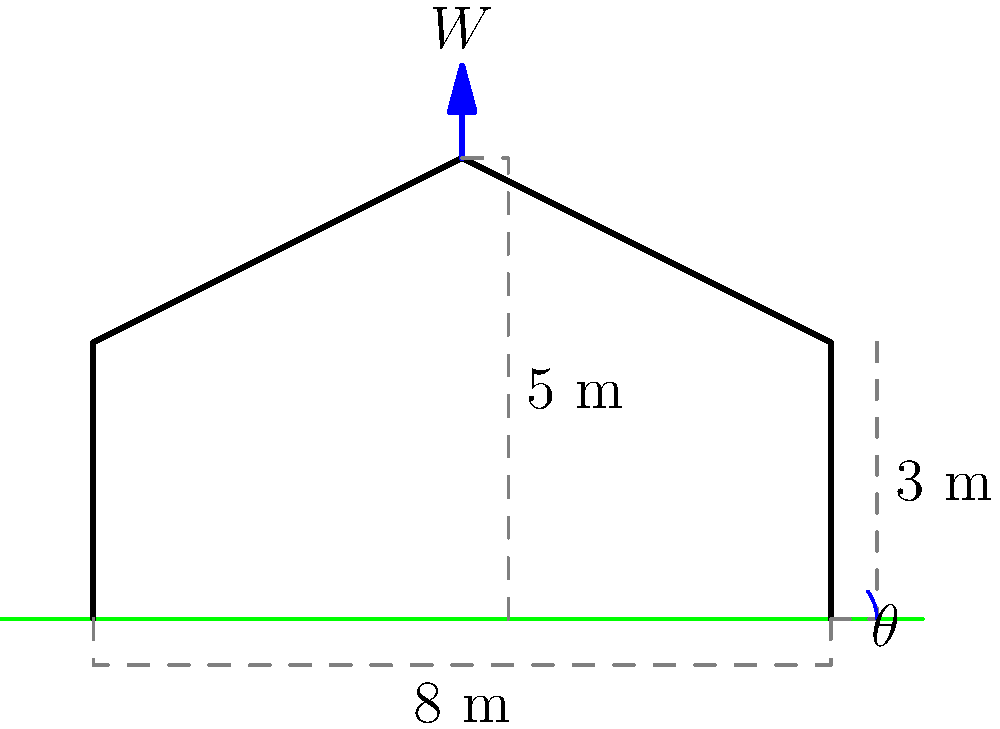As a horticulturist designing a greenhouse for cultivating botanical ingredients, you need to consider its structural integrity. The greenhouse has a symmetrical A-frame design with a span of 8 m and a height of 5 m at the center. The roof angle $\theta$ is 36.87°. If the total roof load $W$ (including snow, wind, and the weight of the structure) is 15 kN/m², what is the horizontal reaction force at one of the supports? To find the horizontal reaction force, we'll follow these steps:

1) First, we need to calculate the total load on one side of the roof:
   Roof length = 5 m / sin(36.87°) ≈ 8.33 m
   Load per meter of span = 15 kN/m² × 8.33 m = 124.95 kN/m

2) The total load on half of the greenhouse:
   $W_{total} = 124.95 \text{ kN/m} \times 4 \text{ m} = 499.8 \text{ kN}$

3) This load acts vertically at the center of the roof span.

4) Due to symmetry, each support bears half of this load vertically:
   $V = 499.8 \text{ kN} / 2 = 249.9 \text{ kN}$

5) The horizontal reaction $H$ and vertical reaction $V$ at the support form the resultant force that must be parallel to the roof to maintain equilibrium.

6) We can use the angle $\theta$ to find the ratio between $H$ and $V$:
   $\tan(\theta) = V / H$

7) Rearranging to solve for $H$:
   $H = V / \tan(\theta) = 249.9 \text{ kN} / \tan(36.87°) = 333.3 \text{ kN}$

Therefore, the horizontal reaction force at one support is approximately 333.3 kN.
Answer: 333.3 kN 